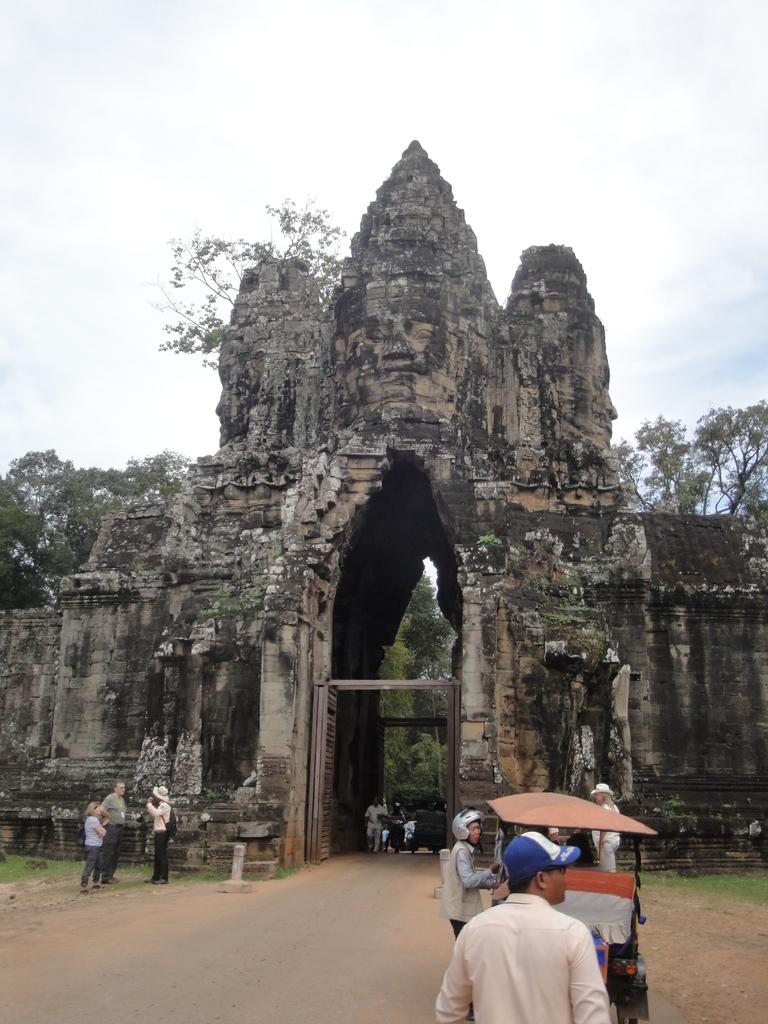What type of architecture can be seen in the image? There is an ancient architecture in the image. How many people are present in the image? There are many people in the image. What is the cart used for in the image? The cart's purpose is not specified, but it is visible in the image. What can be seen in the background of the image? There are trees and the sky visible in the background of the image. What is the condition of the sky in the image? Clouds are present in the sky. What type of cattle can be seen grazing in the image? There is no cattle present in the image; it features ancient architecture, people, a cart, trees, and a sky with clouds. 